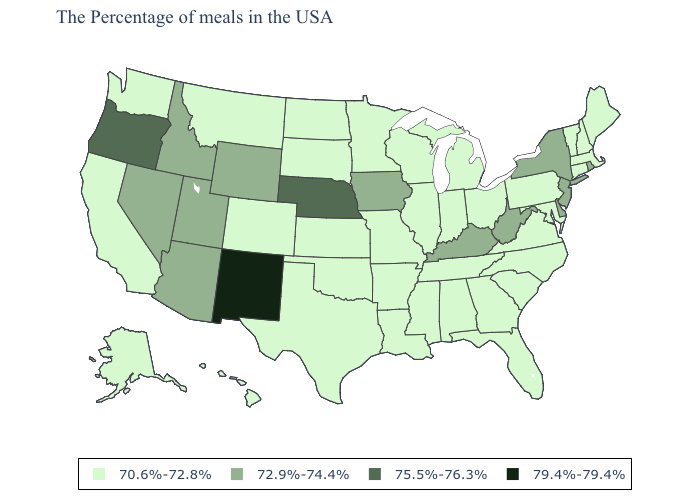Name the states that have a value in the range 75.5%-76.3%?
Give a very brief answer. Nebraska, Oregon. What is the value of Nevada?
Be succinct. 72.9%-74.4%. Does Maine have a lower value than West Virginia?
Be succinct. Yes. What is the highest value in states that border Oregon?
Keep it brief. 72.9%-74.4%. How many symbols are there in the legend?
Write a very short answer. 4. What is the value of Maryland?
Answer briefly. 70.6%-72.8%. Does New Mexico have the highest value in the West?
Short answer required. Yes. Does Connecticut have the lowest value in the Northeast?
Be succinct. Yes. Name the states that have a value in the range 79.4%-79.4%?
Quick response, please. New Mexico. Does the map have missing data?
Quick response, please. No. Name the states that have a value in the range 75.5%-76.3%?
Give a very brief answer. Nebraska, Oregon. Which states have the lowest value in the USA?
Quick response, please. Maine, Massachusetts, New Hampshire, Vermont, Connecticut, Maryland, Pennsylvania, Virginia, North Carolina, South Carolina, Ohio, Florida, Georgia, Michigan, Indiana, Alabama, Tennessee, Wisconsin, Illinois, Mississippi, Louisiana, Missouri, Arkansas, Minnesota, Kansas, Oklahoma, Texas, South Dakota, North Dakota, Colorado, Montana, California, Washington, Alaska, Hawaii. Name the states that have a value in the range 79.4%-79.4%?
Write a very short answer. New Mexico. What is the value of North Carolina?
Quick response, please. 70.6%-72.8%. Which states have the highest value in the USA?
Give a very brief answer. New Mexico. 